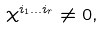Convert formula to latex. <formula><loc_0><loc_0><loc_500><loc_500>\chi ^ { i _ { 1 } \dots i _ { r } } \neq 0 ,</formula> 